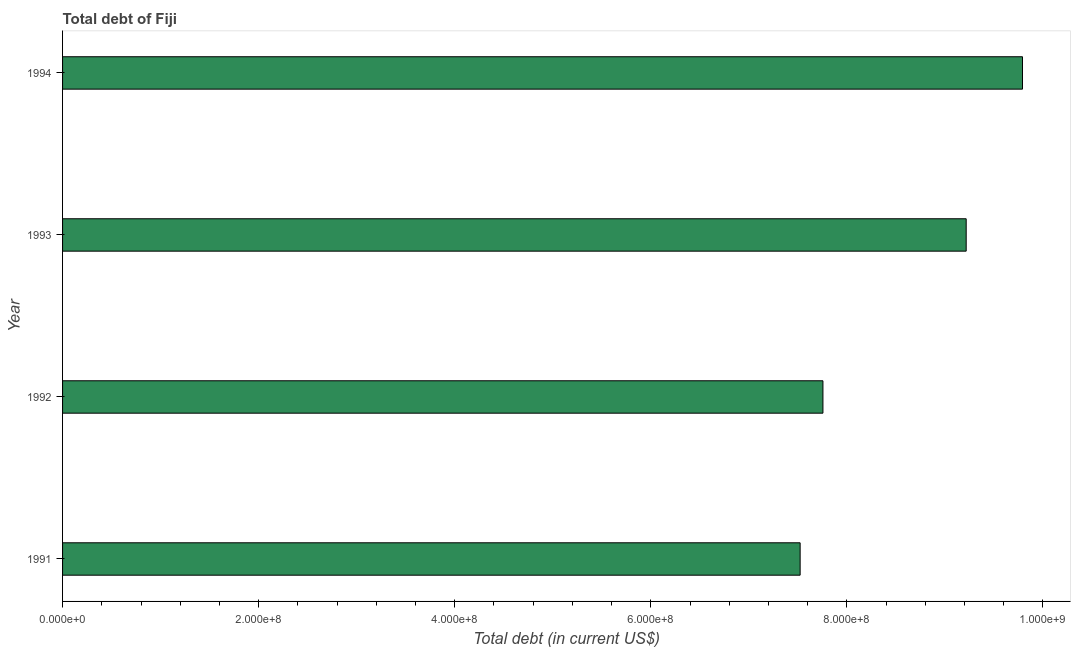Does the graph contain grids?
Give a very brief answer. No. What is the title of the graph?
Offer a very short reply. Total debt of Fiji. What is the label or title of the X-axis?
Make the answer very short. Total debt (in current US$). What is the total debt in 1991?
Provide a short and direct response. 7.52e+08. Across all years, what is the maximum total debt?
Ensure brevity in your answer.  9.79e+08. Across all years, what is the minimum total debt?
Offer a very short reply. 7.52e+08. In which year was the total debt maximum?
Provide a short and direct response. 1994. In which year was the total debt minimum?
Provide a succinct answer. 1991. What is the sum of the total debt?
Your answer should be very brief. 3.43e+09. What is the difference between the total debt in 1992 and 1994?
Offer a very short reply. -2.04e+08. What is the average total debt per year?
Your answer should be very brief. 8.57e+08. What is the median total debt?
Keep it short and to the point. 8.49e+08. In how many years, is the total debt greater than 40000000 US$?
Keep it short and to the point. 4. Do a majority of the years between 1991 and 1994 (inclusive) have total debt greater than 720000000 US$?
Provide a succinct answer. Yes. What is the ratio of the total debt in 1991 to that in 1992?
Keep it short and to the point. 0.97. Is the difference between the total debt in 1991 and 1993 greater than the difference between any two years?
Make the answer very short. No. What is the difference between the highest and the second highest total debt?
Your response must be concise. 5.74e+07. Is the sum of the total debt in 1992 and 1994 greater than the maximum total debt across all years?
Offer a very short reply. Yes. What is the difference between the highest and the lowest total debt?
Your answer should be compact. 2.27e+08. How many bars are there?
Provide a succinct answer. 4. Are all the bars in the graph horizontal?
Your answer should be very brief. Yes. How many years are there in the graph?
Your answer should be very brief. 4. What is the difference between two consecutive major ticks on the X-axis?
Your response must be concise. 2.00e+08. Are the values on the major ticks of X-axis written in scientific E-notation?
Make the answer very short. Yes. What is the Total debt (in current US$) of 1991?
Give a very brief answer. 7.52e+08. What is the Total debt (in current US$) in 1992?
Your answer should be compact. 7.76e+08. What is the Total debt (in current US$) in 1993?
Give a very brief answer. 9.22e+08. What is the Total debt (in current US$) of 1994?
Your response must be concise. 9.79e+08. What is the difference between the Total debt (in current US$) in 1991 and 1992?
Your answer should be very brief. -2.33e+07. What is the difference between the Total debt (in current US$) in 1991 and 1993?
Offer a very short reply. -1.69e+08. What is the difference between the Total debt (in current US$) in 1991 and 1994?
Ensure brevity in your answer.  -2.27e+08. What is the difference between the Total debt (in current US$) in 1992 and 1993?
Offer a terse response. -1.46e+08. What is the difference between the Total debt (in current US$) in 1992 and 1994?
Make the answer very short. -2.04e+08. What is the difference between the Total debt (in current US$) in 1993 and 1994?
Your answer should be compact. -5.74e+07. What is the ratio of the Total debt (in current US$) in 1991 to that in 1992?
Offer a very short reply. 0.97. What is the ratio of the Total debt (in current US$) in 1991 to that in 1993?
Keep it short and to the point. 0.82. What is the ratio of the Total debt (in current US$) in 1991 to that in 1994?
Provide a short and direct response. 0.77. What is the ratio of the Total debt (in current US$) in 1992 to that in 1993?
Your answer should be very brief. 0.84. What is the ratio of the Total debt (in current US$) in 1992 to that in 1994?
Your answer should be compact. 0.79. What is the ratio of the Total debt (in current US$) in 1993 to that in 1994?
Provide a succinct answer. 0.94. 